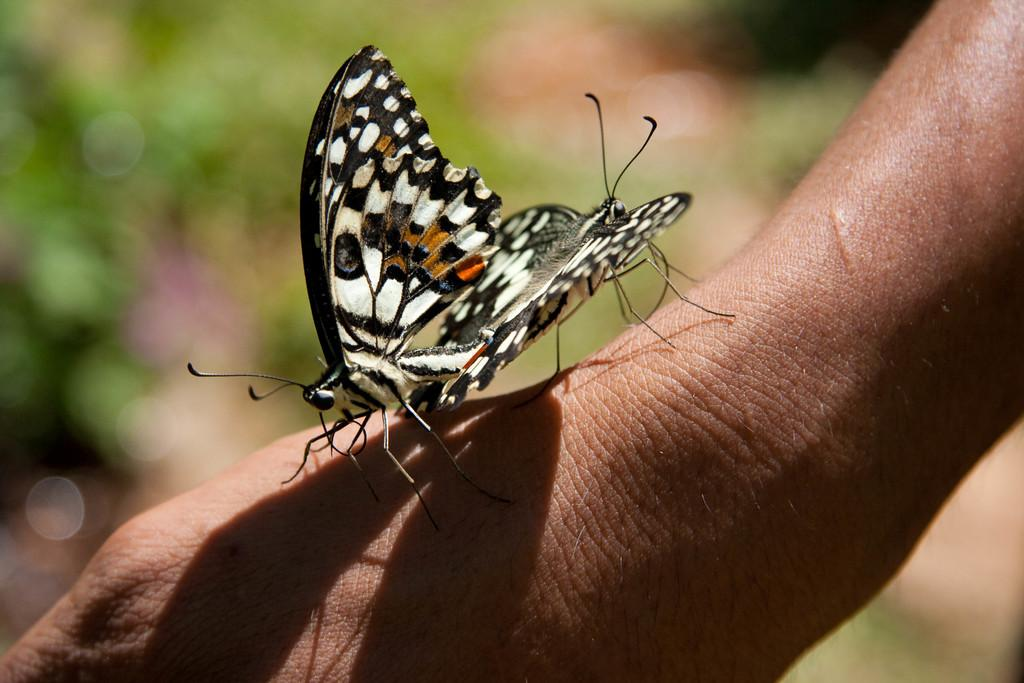How many butterflies are present in the image? There are two butterflies in the image. What are the butterflies doing in the image? The butterflies are standing on a person's hand. What can be seen in the background of the image? There is green grass visible in the background of the image. Is there a wall in the image that the butterflies are flying around? No, there is no wall present in the image. The butterflies are standing on a person's hand, not flying around a wall. 